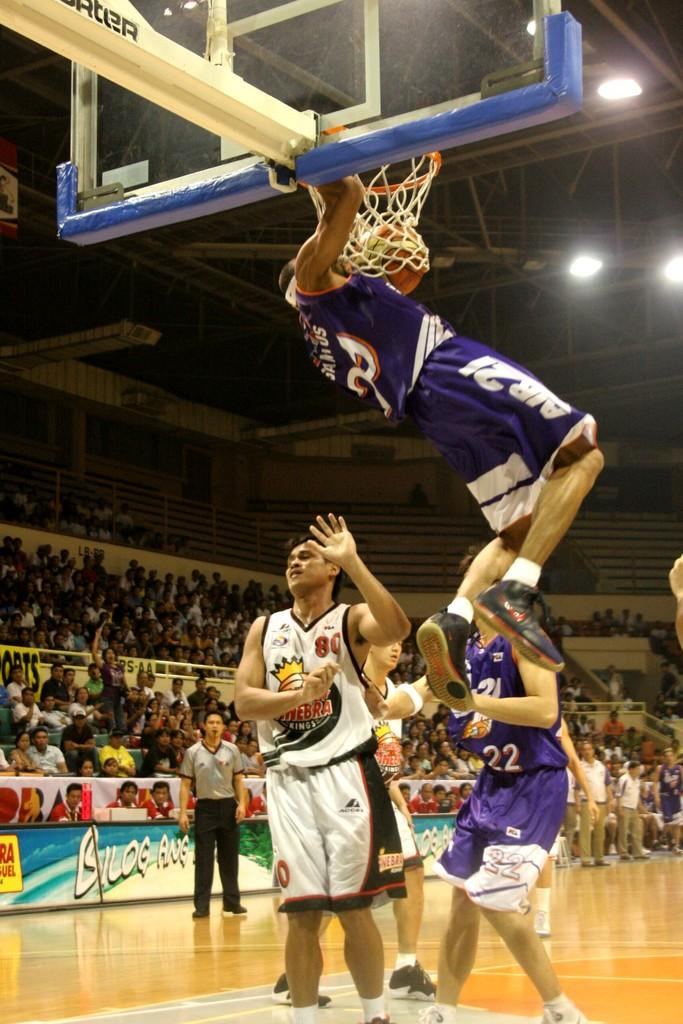Provide a one-sentence caption for the provided image. Number 80 for the Kings just got dunked on. 